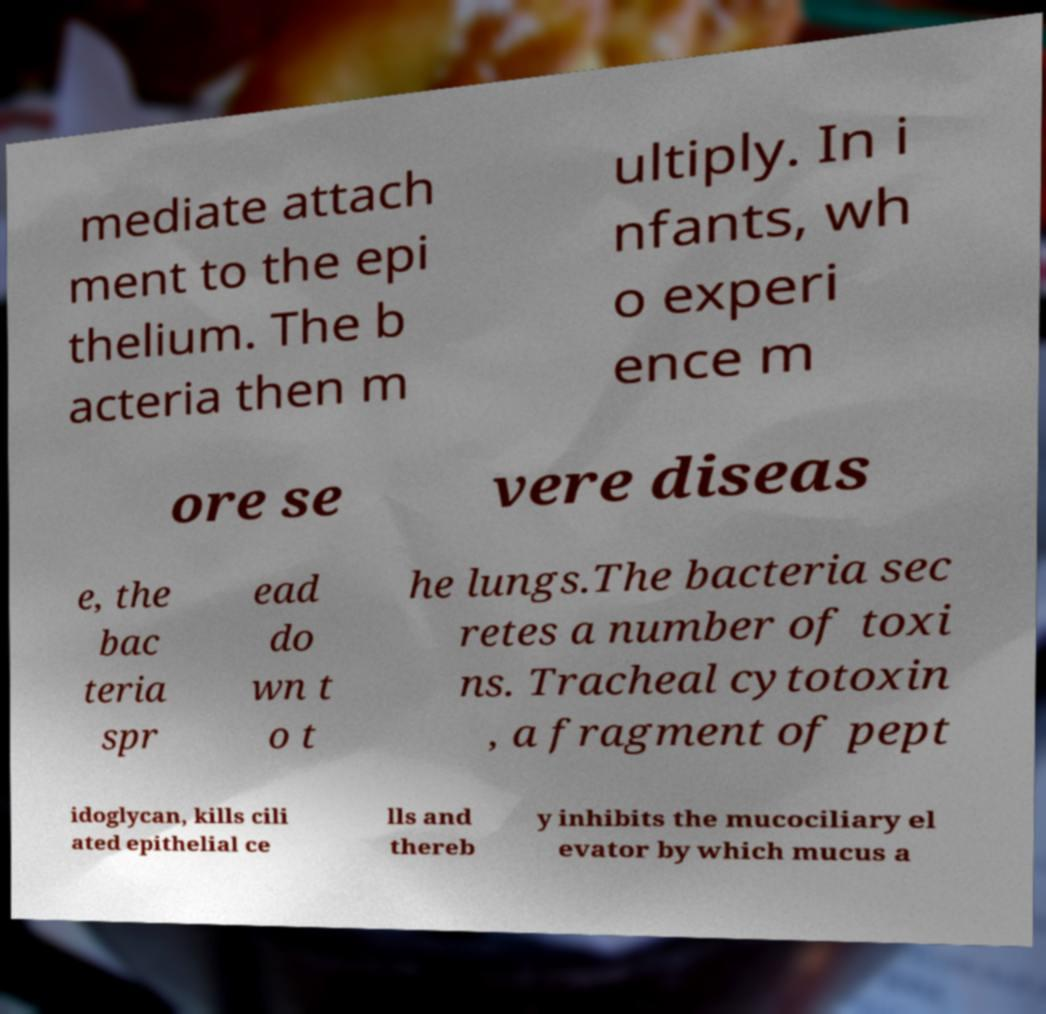There's text embedded in this image that I need extracted. Can you transcribe it verbatim? mediate attach ment to the epi thelium. The b acteria then m ultiply. In i nfants, wh o experi ence m ore se vere diseas e, the bac teria spr ead do wn t o t he lungs.The bacteria sec retes a number of toxi ns. Tracheal cytotoxin , a fragment of pept idoglycan, kills cili ated epithelial ce lls and thereb y inhibits the mucociliary el evator by which mucus a 